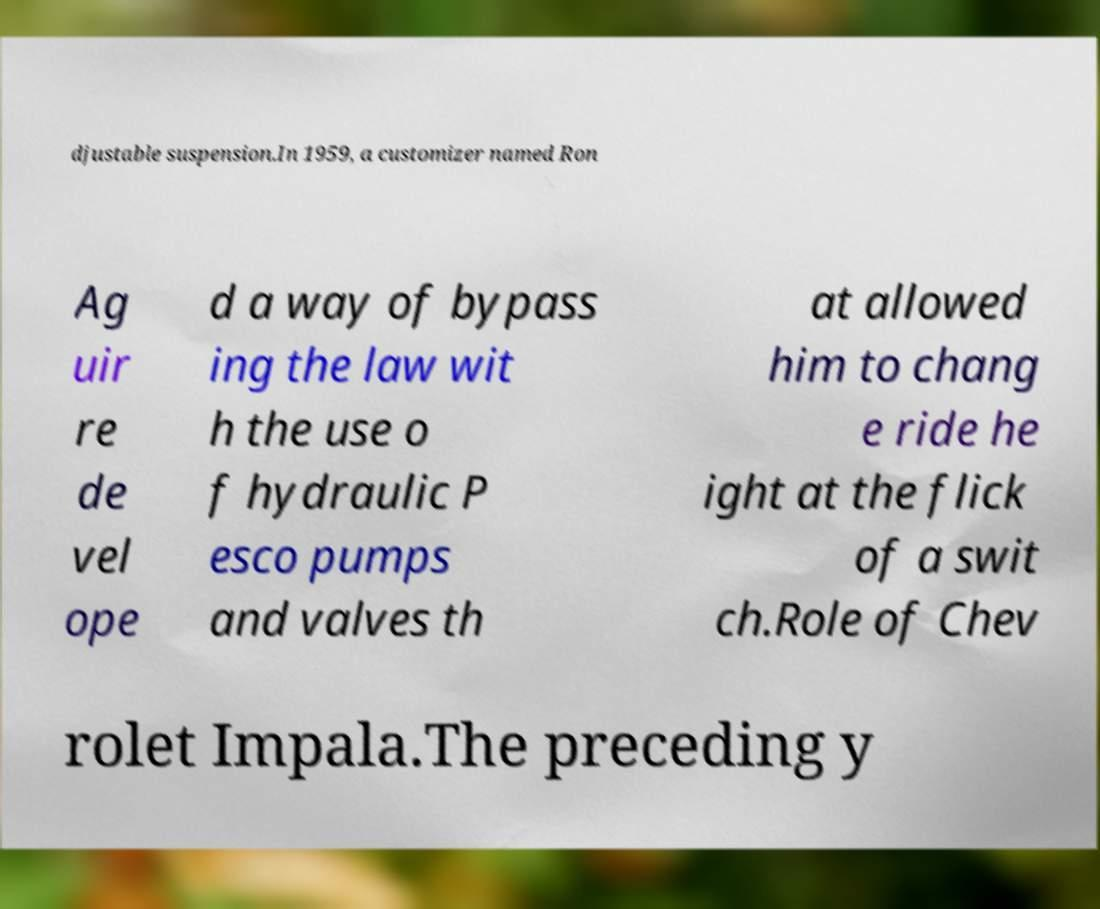Can you accurately transcribe the text from the provided image for me? djustable suspension.In 1959, a customizer named Ron Ag uir re de vel ope d a way of bypass ing the law wit h the use o f hydraulic P esco pumps and valves th at allowed him to chang e ride he ight at the flick of a swit ch.Role of Chev rolet Impala.The preceding y 